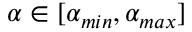Convert formula to latex. <formula><loc_0><loc_0><loc_500><loc_500>\alpha \in [ \alpha _ { \min } , \alpha _ { \max } ]</formula> 